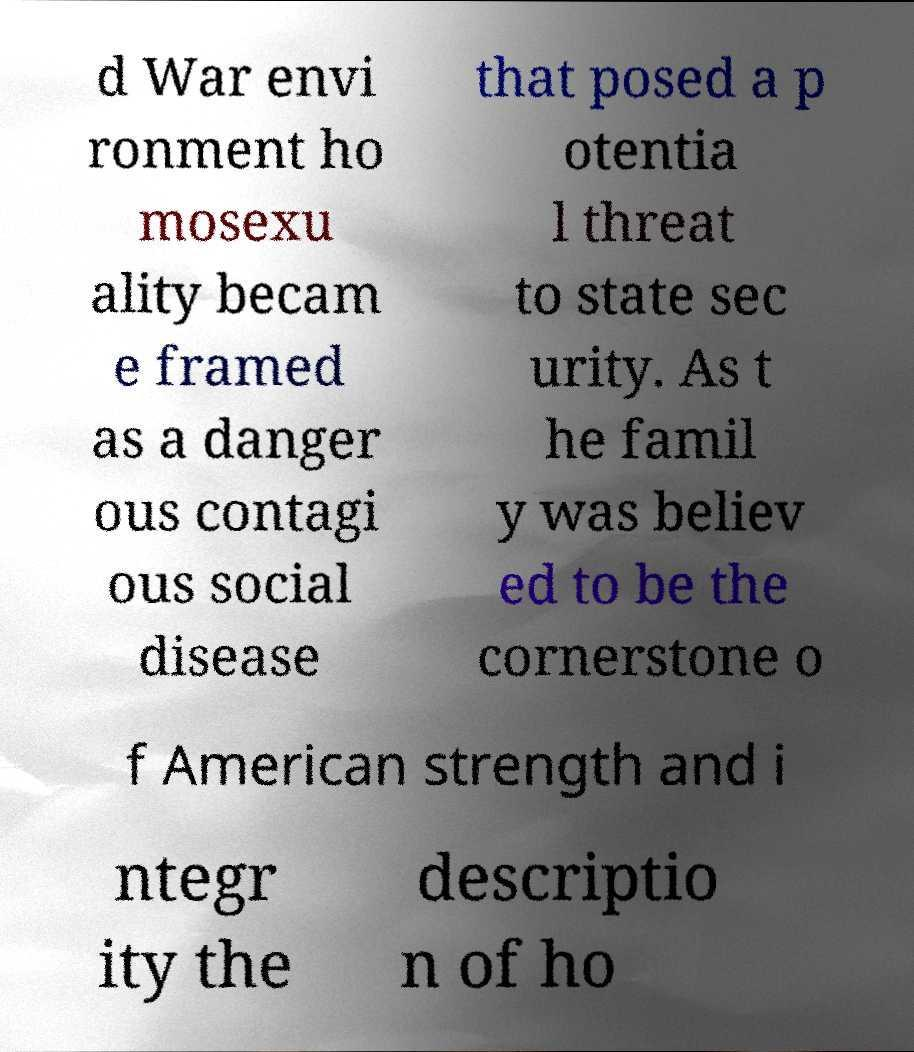Could you extract and type out the text from this image? d War envi ronment ho mosexu ality becam e framed as a danger ous contagi ous social disease that posed a p otentia l threat to state sec urity. As t he famil y was believ ed to be the cornerstone o f American strength and i ntegr ity the descriptio n of ho 